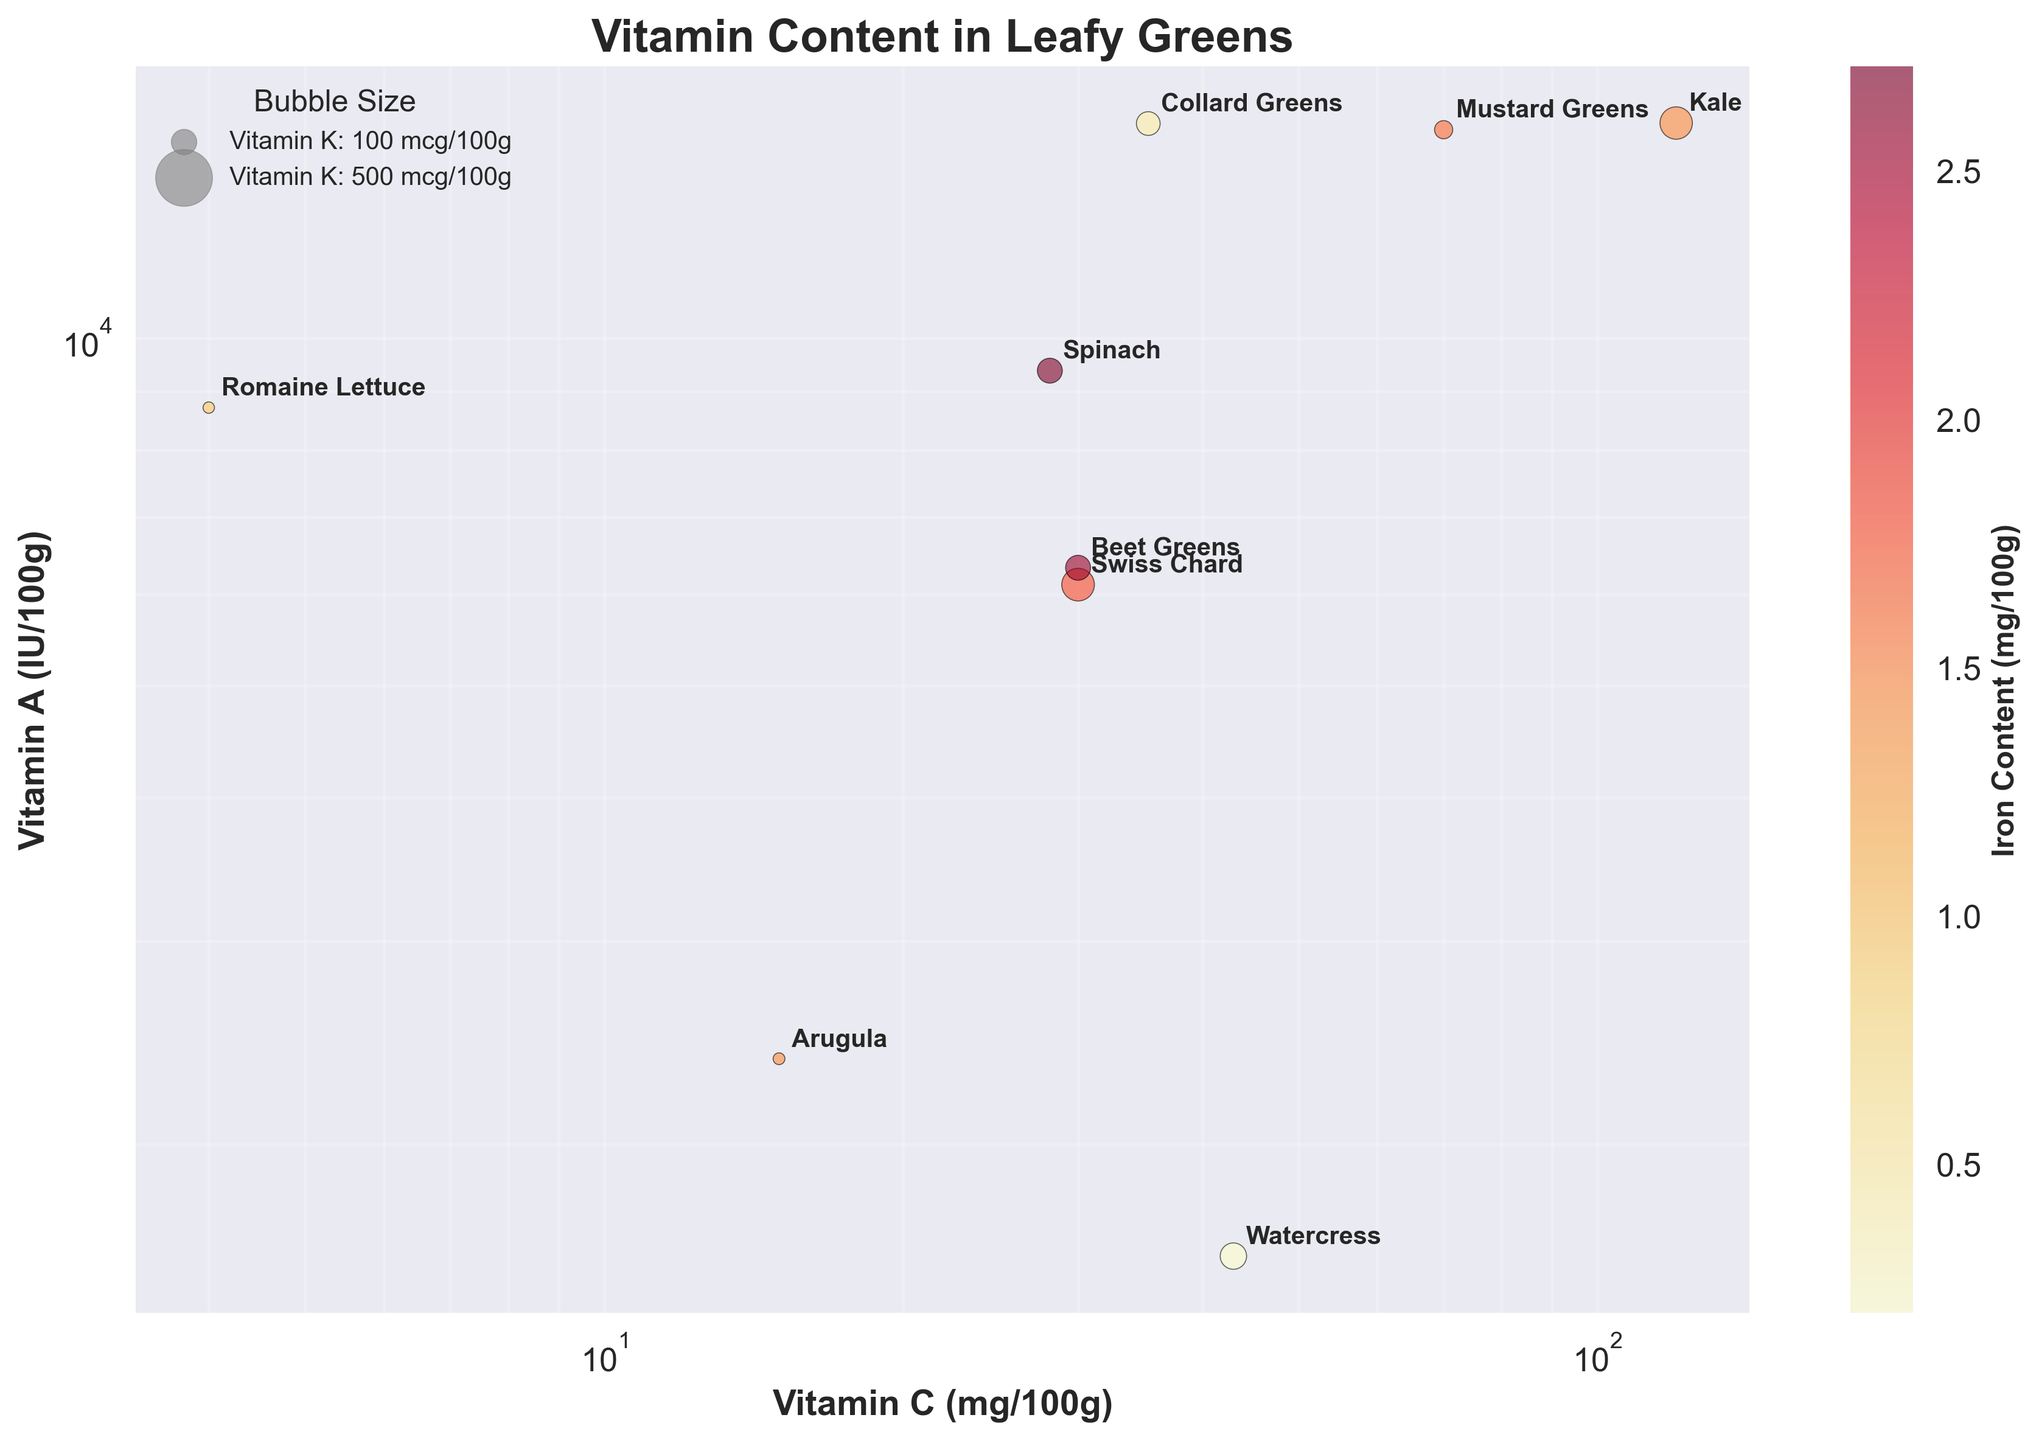What is the title of the bubble chart? The title of the chart is prominently displayed at the top. By simply looking at the top of the plot, we can see that it is labeled "Vitamin Content in Leafy Greens."
Answer: Vitamin Content in Leafy Greens What are the axes labeled with? By examining the plot, we can see that the x-axis is labeled "Vitamin C (mg/100g)" and the y-axis is labeled "Vitamin A (IU/100g)."
Answer: Vitamin C (mg/100g) and Vitamin A (IU/100g) Which leafy green has the highest value of Vitamin C? By looking at the plot, we identify the data point placed farthest to the right on the x-axis labeled "Vitamin C (mg/100g)." Kale is the leafy green with the maximum Vitamin C value of 120 mg/100g.
Answer: Kale Which leafy green has the highest Vitamin A content? By looking at the plot, we observe the data point placed the highest on the y-axis labeled "Vitamin A (IU/100g)." The kale data point is highest with 15376 IU/100g of Vitamin A.
Answer: Kale Which leafy green has the largest bubble size and what does it represent? Examining the plot, we identify the bubble with the highest size. The Swiss Chard data point has the largest bubble, representing the highest Vitamin K content, indicating 830 mcg/100g.
Answer: Swiss Chard, 830 mcg/100g Which leafy green has the highest Iron content? By referring to the color intensity shown in the color bar (ranging from yellow to dark red), we can see that the darkest red bubble, indicating the highest Iron content, belongs to Spinach.
Answer: Spinach How does the Vitamin C content of Arugula compare to that of Romaine Lettuce? Checking the x-axis positions of Arugula and Romaine Lettuce, Arugula is at 15 mg/100g and Romaine Lettuce is at 4 mg/100g. Arugula has a higher value of Vitamin C compared to Romaine Lettuce.
Answer: Arugula > Romaine Lettuce Does any leafy green have both high Vitamin A and high Iron content? To answer this, we need to look at both axes and the bubble color. Spinach, located near the top with a dark color, has both relatively high Vitamin A (9377 IU/100g) and Iron content (2.71 mg/100g).
Answer: Spinach Which leafy green is labeled near the middle of the chart for Vitamin A and low on Vitamin C? By checking centrally placed points for Vitamin A and relatively lower x-axis values, Watercress stands out with moderate Vitamin A (1600 IU/100g) and low Vitamin C (43 mg/100g).
Answer: Watercress What is the relationship between bubble size and the color of the bubbles in the chart? Observing the chart, we notice that generally, larger bubbles relating to Vitamin K content do not have a noticeable consistent pattern regarding color (Iron content). For instance, large bubbles such as Swiss Chard and Kale have different color intensities.
Answer: No clear relationship 